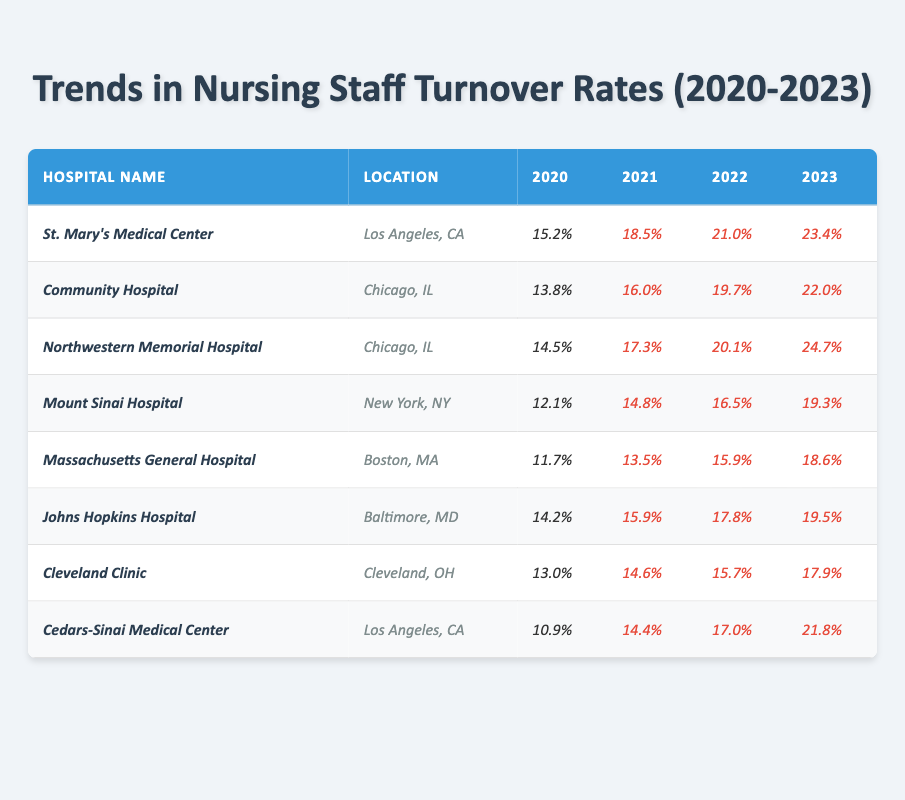What is the highest turnover rate in 2023? The highest turnover rate in 2023 is found in Northwestern Memorial Hospital, which has a rate of 24.7%.
Answer: 24.7% Which hospital had the lowest turnover rate in 2020? The hospital with the lowest turnover rate in 2020 is Massachusetts General Hospital, with a rate of 11.7%.
Answer: 11.7% How much did the turnover rate increase for Cedars-Sinai Medical Center from 2020 to 2023? To find this, subtract the 2020 rate (10.9%) from the 2023 rate (21.8%). The increase is 21.8% - 10.9% = 10.9%.
Answer: 10.9% True or False: The turnover rate at Johns Hopkins Hospital decreased from 2020 to 2023. By comparing the rates from 2020 (14.2%) to 2023 (19.5%), we see that it actually increased.
Answer: False What is the average turnover rate for Community Hospital from 2020 to 2023? We first add the turnover rates: 13.8% + 16.0% + 19.7% + 22.0% = 71.5%. Then, divide by 4 (the number of years) to find the average: 71.5% / 4 = 17.875%.
Answer: 17.88% Which two hospitals had the highest turnover rate in 2022? In 2022, Northwestern Memorial Hospital (20.1%) and St. Mary’s Medical Center (21.0%) had the highest turnover rates.
Answer: Northwestern Memorial and St. Mary’s What was the turnover rate increase for Massachusetts General Hospital between 2020 and 2023? Get the increase by subtracting the 2020 rate (11.7%) from the 2023 rate (18.6%): 18.6% - 11.7% = 6.9%.
Answer: 6.9% Which location has the highest number of hospitals listed? Chicago, IL has two hospitals listed: Community Hospital and Northwestern Memorial Hospital.
Answer: Chicago, IL What is the overall trend in nursing turnover rates from 2020 to 2023 across all hospitals? To determine this, observe each hospital’s turnover rates across the years, noting they all increased, indicating an upward trend in turnover rates over the years.
Answer: Upward trend 